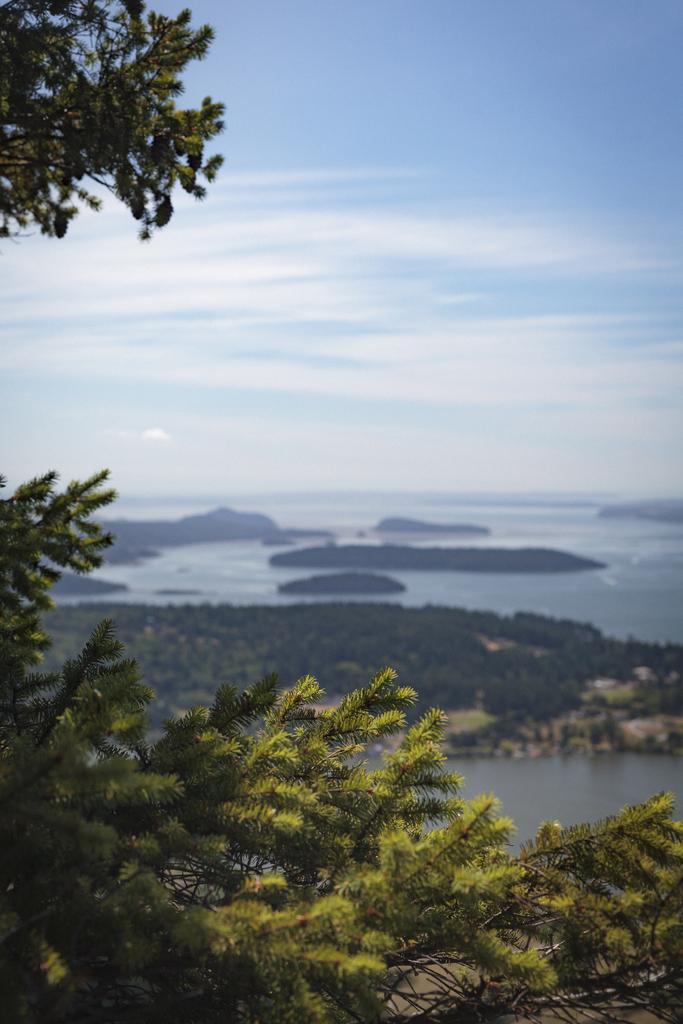Could you give a brief overview of what you see in this image? In this picture we can see trees and water and in the background we can see sky with clouds. 